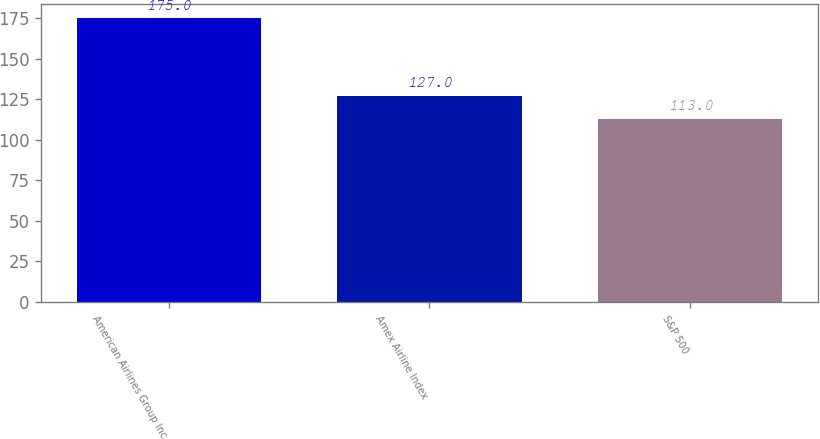<chart> <loc_0><loc_0><loc_500><loc_500><bar_chart><fcel>American Airlines Group Inc<fcel>Amex Airline Index<fcel>S&P 500<nl><fcel>175<fcel>127<fcel>113<nl></chart> 